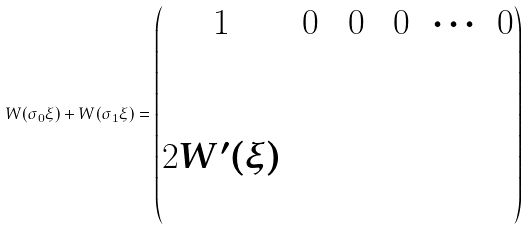Convert formula to latex. <formula><loc_0><loc_0><loc_500><loc_500>W ( \sigma _ { 0 } \xi ) + W ( \sigma _ { 1 } \xi ) = \begin{pmatrix} 1 & \, 0 \, & \, 0 \, & \, 0 \, & \cdots & 0 \\ \\ & & & & & \\ 2 W ^ { \prime } ( \xi ) & & & & & \\ & & & & & \\ \end{pmatrix}</formula> 